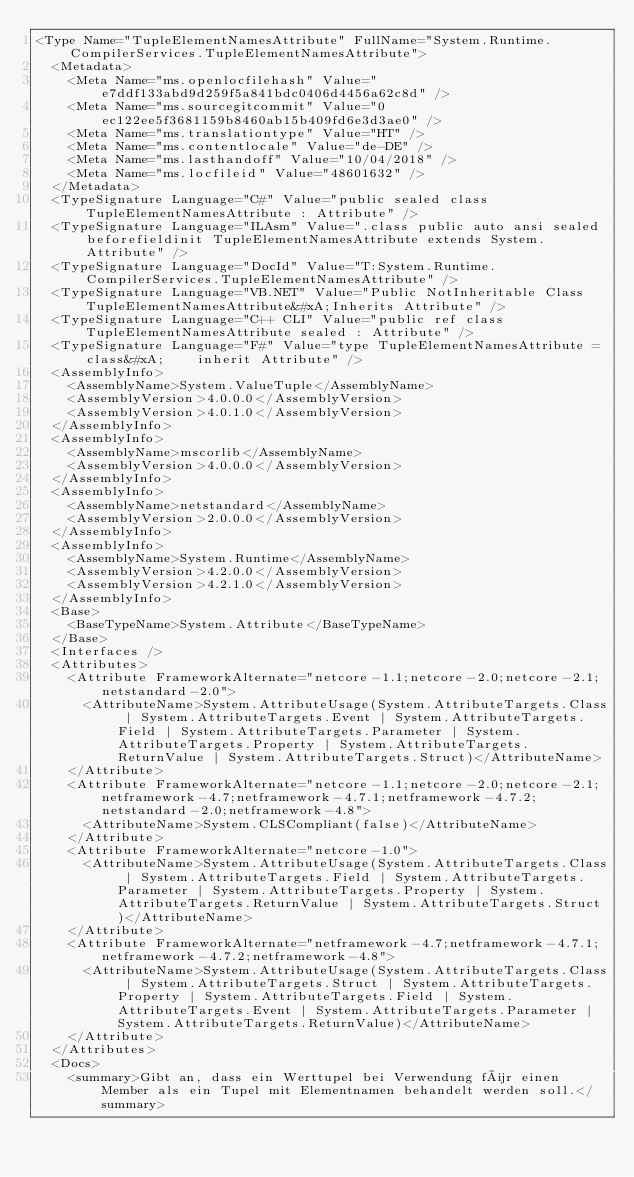<code> <loc_0><loc_0><loc_500><loc_500><_XML_><Type Name="TupleElementNamesAttribute" FullName="System.Runtime.CompilerServices.TupleElementNamesAttribute">
  <Metadata>
    <Meta Name="ms.openlocfilehash" Value="e7ddf133abd9d259f5a841bdc0406d4456a62c8d" />
    <Meta Name="ms.sourcegitcommit" Value="0ec122ee5f3681159b8460ab15b409fd6e3d3ae0" />
    <Meta Name="ms.translationtype" Value="HT" />
    <Meta Name="ms.contentlocale" Value="de-DE" />
    <Meta Name="ms.lasthandoff" Value="10/04/2018" />
    <Meta Name="ms.locfileid" Value="48601632" />
  </Metadata>
  <TypeSignature Language="C#" Value="public sealed class TupleElementNamesAttribute : Attribute" />
  <TypeSignature Language="ILAsm" Value=".class public auto ansi sealed beforefieldinit TupleElementNamesAttribute extends System.Attribute" />
  <TypeSignature Language="DocId" Value="T:System.Runtime.CompilerServices.TupleElementNamesAttribute" />
  <TypeSignature Language="VB.NET" Value="Public NotInheritable Class TupleElementNamesAttribute&#xA;Inherits Attribute" />
  <TypeSignature Language="C++ CLI" Value="public ref class TupleElementNamesAttribute sealed : Attribute" />
  <TypeSignature Language="F#" Value="type TupleElementNamesAttribute = class&#xA;    inherit Attribute" />
  <AssemblyInfo>
    <AssemblyName>System.ValueTuple</AssemblyName>
    <AssemblyVersion>4.0.0.0</AssemblyVersion>
    <AssemblyVersion>4.0.1.0</AssemblyVersion>
  </AssemblyInfo>
  <AssemblyInfo>
    <AssemblyName>mscorlib</AssemblyName>
    <AssemblyVersion>4.0.0.0</AssemblyVersion>
  </AssemblyInfo>
  <AssemblyInfo>
    <AssemblyName>netstandard</AssemblyName>
    <AssemblyVersion>2.0.0.0</AssemblyVersion>
  </AssemblyInfo>
  <AssemblyInfo>
    <AssemblyName>System.Runtime</AssemblyName>
    <AssemblyVersion>4.2.0.0</AssemblyVersion>
    <AssemblyVersion>4.2.1.0</AssemblyVersion>
  </AssemblyInfo>
  <Base>
    <BaseTypeName>System.Attribute</BaseTypeName>
  </Base>
  <Interfaces />
  <Attributes>
    <Attribute FrameworkAlternate="netcore-1.1;netcore-2.0;netcore-2.1;netstandard-2.0">
      <AttributeName>System.AttributeUsage(System.AttributeTargets.Class | System.AttributeTargets.Event | System.AttributeTargets.Field | System.AttributeTargets.Parameter | System.AttributeTargets.Property | System.AttributeTargets.ReturnValue | System.AttributeTargets.Struct)</AttributeName>
    </Attribute>
    <Attribute FrameworkAlternate="netcore-1.1;netcore-2.0;netcore-2.1;netframework-4.7;netframework-4.7.1;netframework-4.7.2;netstandard-2.0;netframework-4.8">
      <AttributeName>System.CLSCompliant(false)</AttributeName>
    </Attribute>
    <Attribute FrameworkAlternate="netcore-1.0">
      <AttributeName>System.AttributeUsage(System.AttributeTargets.Class | System.AttributeTargets.Field | System.AttributeTargets.Parameter | System.AttributeTargets.Property | System.AttributeTargets.ReturnValue | System.AttributeTargets.Struct)</AttributeName>
    </Attribute>
    <Attribute FrameworkAlternate="netframework-4.7;netframework-4.7.1;netframework-4.7.2;netframework-4.8">
      <AttributeName>System.AttributeUsage(System.AttributeTargets.Class | System.AttributeTargets.Struct | System.AttributeTargets.Property | System.AttributeTargets.Field | System.AttributeTargets.Event | System.AttributeTargets.Parameter | System.AttributeTargets.ReturnValue)</AttributeName>
    </Attribute>
  </Attributes>
  <Docs>
    <summary>Gibt an, dass ein Werttupel bei Verwendung für einen Member als ein Tupel mit Elementnamen behandelt werden soll.</summary></code> 